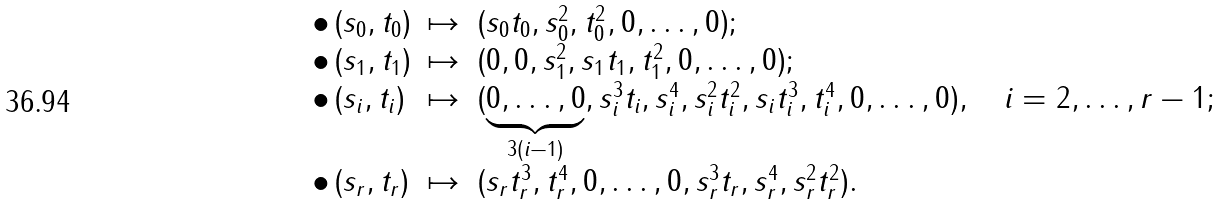<formula> <loc_0><loc_0><loc_500><loc_500>\begin{array} { l c l } \bullet \, ( s _ { 0 } , t _ { 0 } ) & \mapsto & ( s _ { 0 } t _ { 0 } , s _ { 0 } ^ { 2 } , t _ { 0 } ^ { 2 } , 0 , \dots , 0 ) ; \\ \bullet \, ( s _ { 1 } , t _ { 1 } ) & \mapsto & ( 0 , 0 , s _ { 1 } ^ { 2 } , s _ { 1 } t _ { 1 } , t _ { 1 } ^ { 2 } , 0 , \dots , 0 ) ; \\ \bullet \, ( s _ { i } , t _ { i } ) & \mapsto & ( \underbrace { 0 , \dots , 0 } _ { 3 ( i - 1 ) } , s _ { i } ^ { 3 } t _ { i } , s _ { i } ^ { 4 } , s _ { i } ^ { 2 } t _ { i } ^ { 2 } , s _ { i } t _ { i } ^ { 3 } , t _ { i } ^ { 4 } , 0 , \dots , 0 ) , \quad i = 2 , \dots , r - 1 ; \\ \bullet \, ( s _ { r } , t _ { r } ) & \mapsto & ( s _ { r } t _ { r } ^ { 3 } , t _ { r } ^ { 4 } , 0 , \dots , 0 , s _ { r } ^ { 3 } t _ { r } , s _ { r } ^ { 4 } , s _ { r } ^ { 2 } t _ { r } ^ { 2 } ) . \end{array}</formula> 